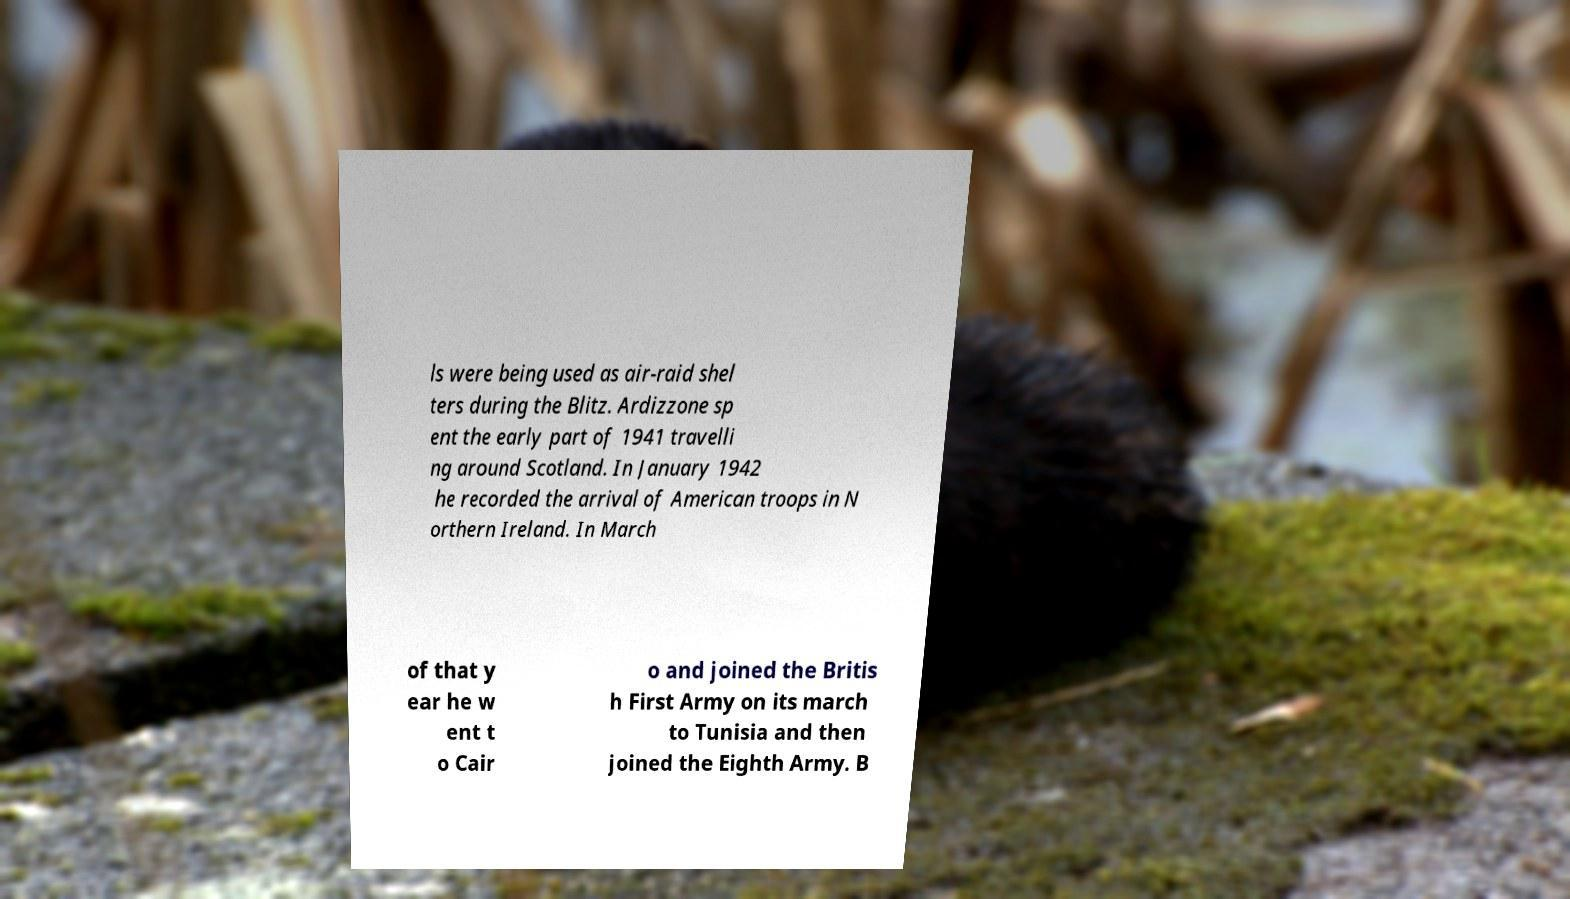Could you assist in decoding the text presented in this image and type it out clearly? ls were being used as air-raid shel ters during the Blitz. Ardizzone sp ent the early part of 1941 travelli ng around Scotland. In January 1942 he recorded the arrival of American troops in N orthern Ireland. In March of that y ear he w ent t o Cair o and joined the Britis h First Army on its march to Tunisia and then joined the Eighth Army. B 